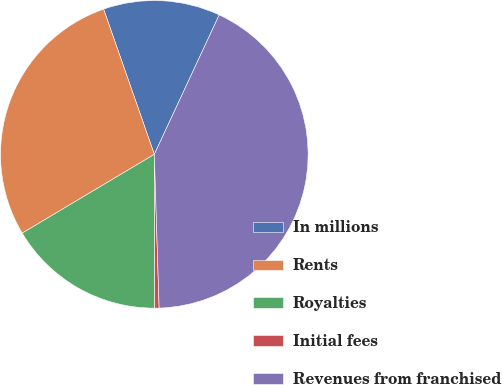Convert chart. <chart><loc_0><loc_0><loc_500><loc_500><pie_chart><fcel>In millions<fcel>Rents<fcel>Royalties<fcel>Initial fees<fcel>Revenues from franchised<nl><fcel>12.28%<fcel>28.21%<fcel>16.49%<fcel>0.45%<fcel>42.57%<nl></chart> 